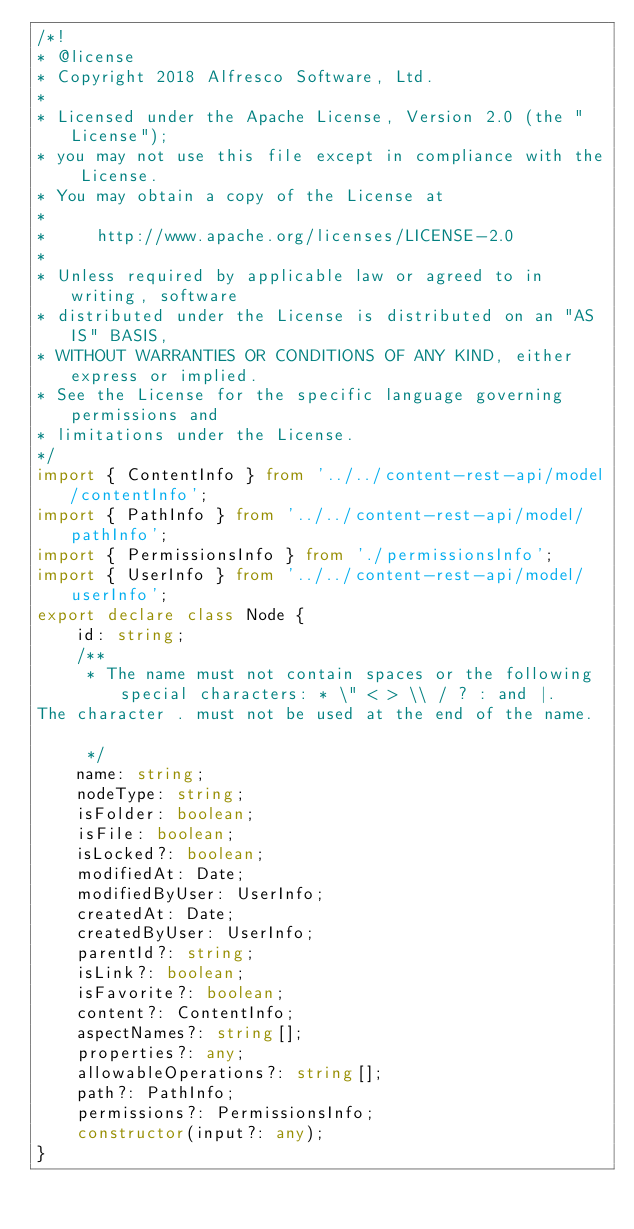<code> <loc_0><loc_0><loc_500><loc_500><_TypeScript_>/*!
* @license
* Copyright 2018 Alfresco Software, Ltd.
*
* Licensed under the Apache License, Version 2.0 (the "License");
* you may not use this file except in compliance with the License.
* You may obtain a copy of the License at
*
*     http://www.apache.org/licenses/LICENSE-2.0
*
* Unless required by applicable law or agreed to in writing, software
* distributed under the License is distributed on an "AS IS" BASIS,
* WITHOUT WARRANTIES OR CONDITIONS OF ANY KIND, either express or implied.
* See the License for the specific language governing permissions and
* limitations under the License.
*/
import { ContentInfo } from '../../content-rest-api/model/contentInfo';
import { PathInfo } from '../../content-rest-api/model/pathInfo';
import { PermissionsInfo } from './permissionsInfo';
import { UserInfo } from '../../content-rest-api/model/userInfo';
export declare class Node {
    id: string;
    /**
     * The name must not contain spaces or the following special characters: * \" < > \\ / ? : and |.
The character . must not be used at the end of the name.

     */
    name: string;
    nodeType: string;
    isFolder: boolean;
    isFile: boolean;
    isLocked?: boolean;
    modifiedAt: Date;
    modifiedByUser: UserInfo;
    createdAt: Date;
    createdByUser: UserInfo;
    parentId?: string;
    isLink?: boolean;
    isFavorite?: boolean;
    content?: ContentInfo;
    aspectNames?: string[];
    properties?: any;
    allowableOperations?: string[];
    path?: PathInfo;
    permissions?: PermissionsInfo;
    constructor(input?: any);
}
</code> 